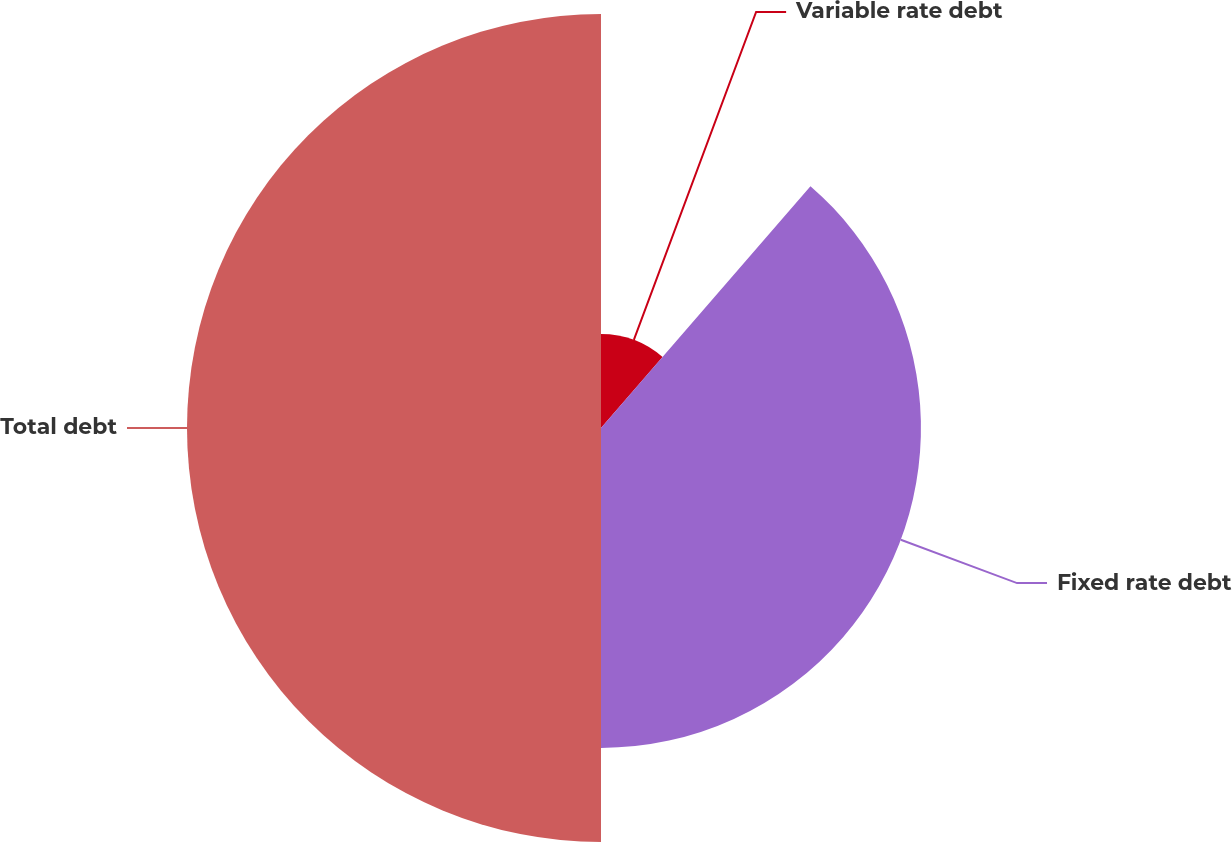Convert chart. <chart><loc_0><loc_0><loc_500><loc_500><pie_chart><fcel>Variable rate debt<fcel>Fixed rate debt<fcel>Total debt<nl><fcel>11.36%<fcel>38.64%<fcel>50.0%<nl></chart> 